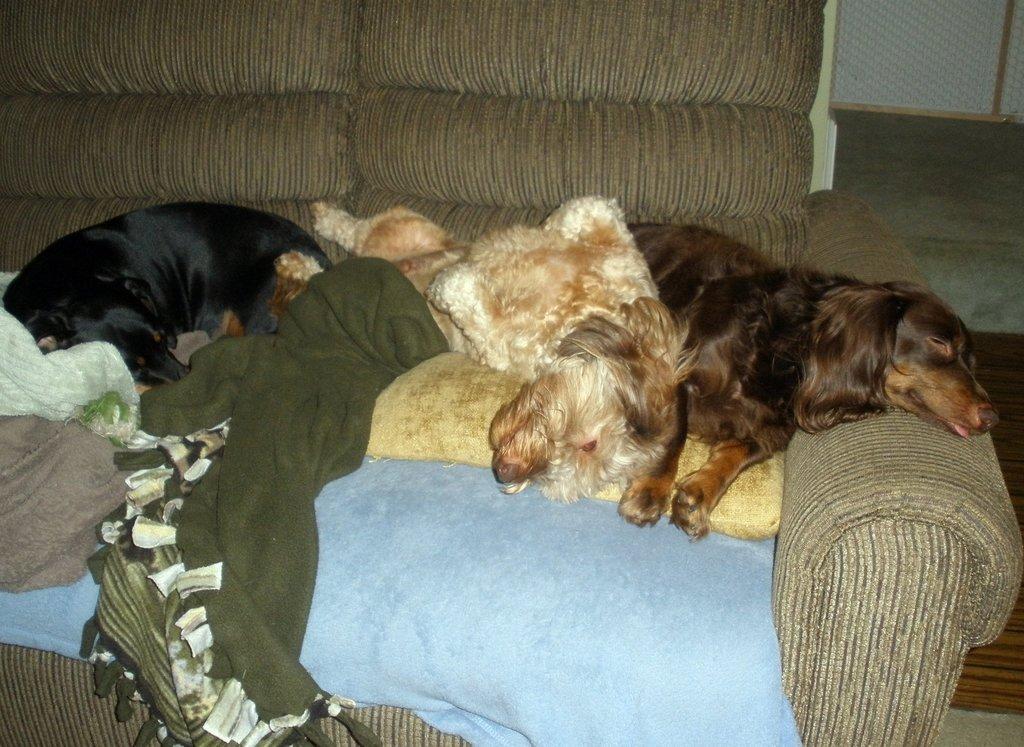Describe this image in one or two sentences. Here in this picture we can see a group of dogs lying on a sofa present over a place. 